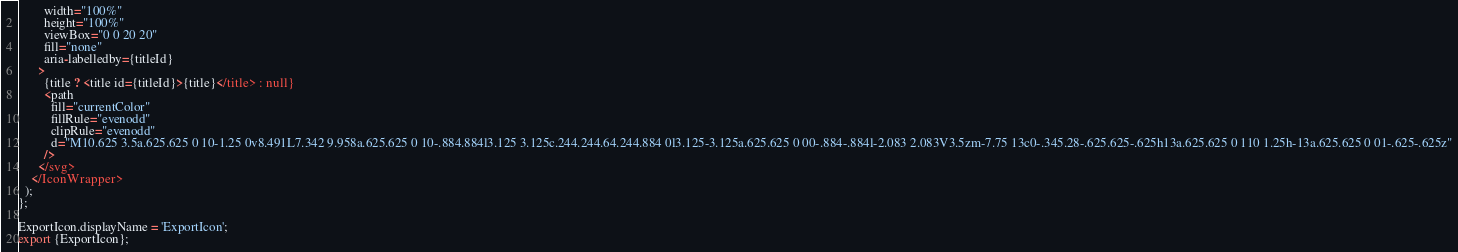Convert code to text. <code><loc_0><loc_0><loc_500><loc_500><_TypeScript_>        width="100%"
        height="100%"
        viewBox="0 0 20 20"
        fill="none"
        aria-labelledby={titleId}
      >
        {title ? <title id={titleId}>{title}</title> : null}
        <path
          fill="currentColor"
          fillRule="evenodd"
          clipRule="evenodd"
          d="M10.625 3.5a.625.625 0 10-1.25 0v8.491L7.342 9.958a.625.625 0 10-.884.884l3.125 3.125c.244.244.64.244.884 0l3.125-3.125a.625.625 0 00-.884-.884l-2.083 2.083V3.5zm-7.75 13c0-.345.28-.625.625-.625h13a.625.625 0 110 1.25h-13a.625.625 0 01-.625-.625z"
        />
      </svg>
    </IconWrapper>
  );
};

ExportIcon.displayName = 'ExportIcon';
export {ExportIcon};
</code> 